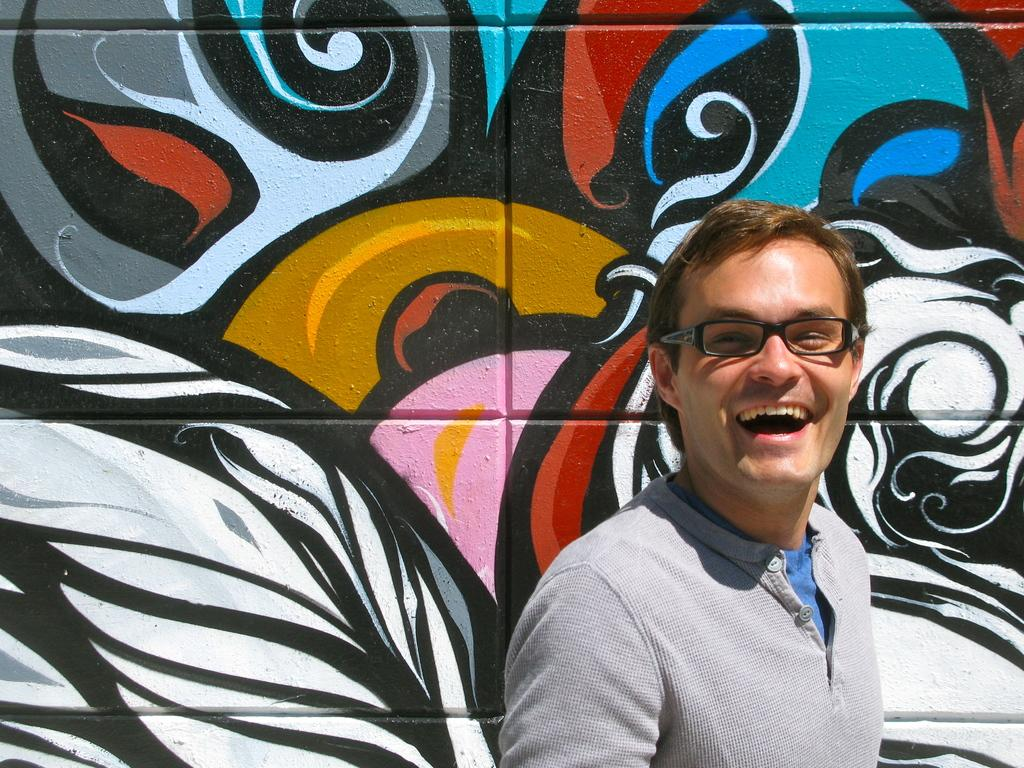What is present in the image? There is a person and paintings on a wall in the image. Can you describe the setting of the image? The image appears to have been taken during the day. Reasoning: Let' Let's think step by step in order to produce the conversation. We start by identifying the main subjects in the image, which are the person and the paintings on the wall. Then, we describe the setting of the image, noting that it appears to have been taken during the day. We avoid yes/no questions and ensure that the language is simple and clear. Absurd Question/Answer: Where is the throne located in the image? There is no throne present in the image. How many giants can be seen in the image? There are no giants present in the image. What is the weight of the person in the image? The weight of the person in the image cannot be determined from the image alone. 